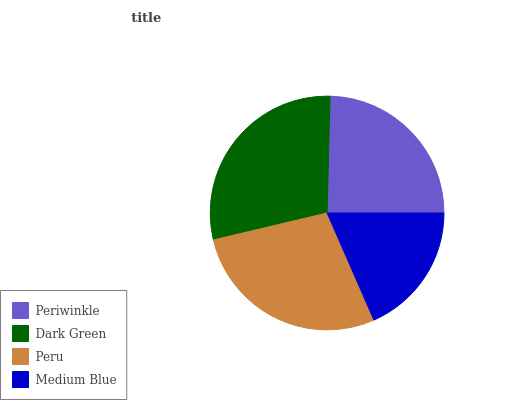Is Medium Blue the minimum?
Answer yes or no. Yes. Is Dark Green the maximum?
Answer yes or no. Yes. Is Peru the minimum?
Answer yes or no. No. Is Peru the maximum?
Answer yes or no. No. Is Dark Green greater than Peru?
Answer yes or no. Yes. Is Peru less than Dark Green?
Answer yes or no. Yes. Is Peru greater than Dark Green?
Answer yes or no. No. Is Dark Green less than Peru?
Answer yes or no. No. Is Peru the high median?
Answer yes or no. Yes. Is Periwinkle the low median?
Answer yes or no. Yes. Is Medium Blue the high median?
Answer yes or no. No. Is Peru the low median?
Answer yes or no. No. 